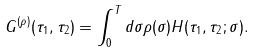Convert formula to latex. <formula><loc_0><loc_0><loc_500><loc_500>G ^ { ( \rho ) } ( \tau _ { 1 } , \tau _ { 2 } ) = \int _ { 0 } ^ { T } d \sigma \rho ( \sigma ) H ( \tau _ { 1 } , \tau _ { 2 } ; \sigma ) .</formula> 